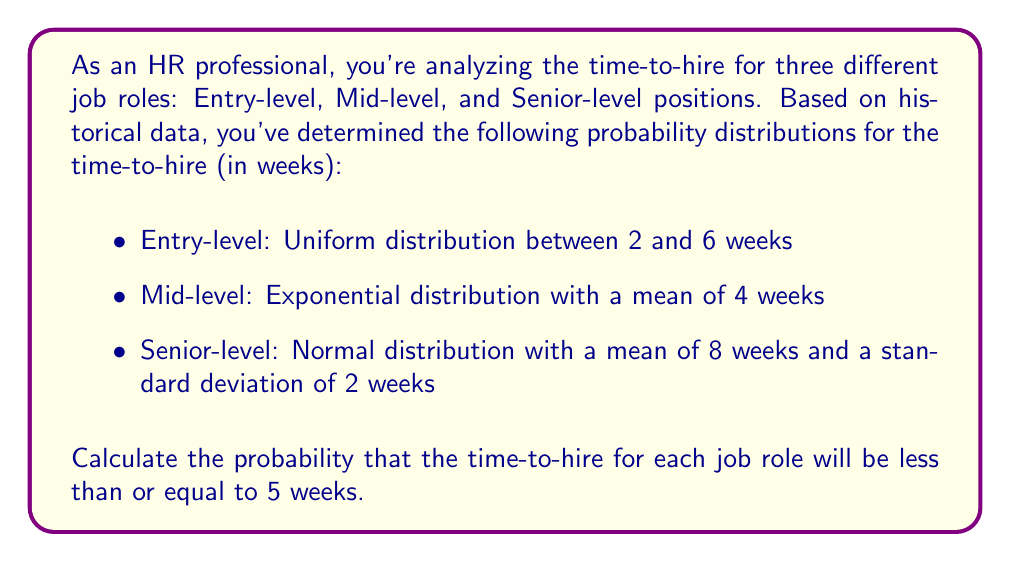Help me with this question. Let's calculate the probability for each job role separately:

1. Entry-level (Uniform distribution):
The probability density function (PDF) for a uniform distribution is constant over its range:
$$f(x) = \frac{1}{b-a}, \text{ for } a \leq x \leq b$$
where $a=2$ and $b=6$.

The cumulative distribution function (CDF) for $x \leq 5$ is:
$$F(5) = \int_2^5 \frac{1}{6-2} dx = \frac{5-2}{6-2} = \frac{3}{4} = 0.75$$

2. Mid-level (Exponential distribution):
The CDF for an exponential distribution is:
$$F(x) = 1 - e^{-\lambda x}$$
where $\lambda = \frac{1}{\text{mean}} = \frac{1}{4}$

For $x \leq 5$:
$$F(5) = 1 - e^{-\frac{1}{4} \cdot 5} = 1 - e^{-1.25} \approx 0.7135$$

3. Senior-level (Normal distribution):
For a normal distribution with mean $\mu=8$ and standard deviation $\sigma=2$, we need to calculate:
$$P(X \leq 5) = P\left(Z \leq \frac{5-8}{2}\right) = P(Z \leq -1.5)$$

Using a standard normal table or calculator:
$$P(Z \leq -1.5) \approx 0.0668$$
Answer: Entry-level: 0.75, Mid-level: 0.7135, Senior-level: 0.0668 